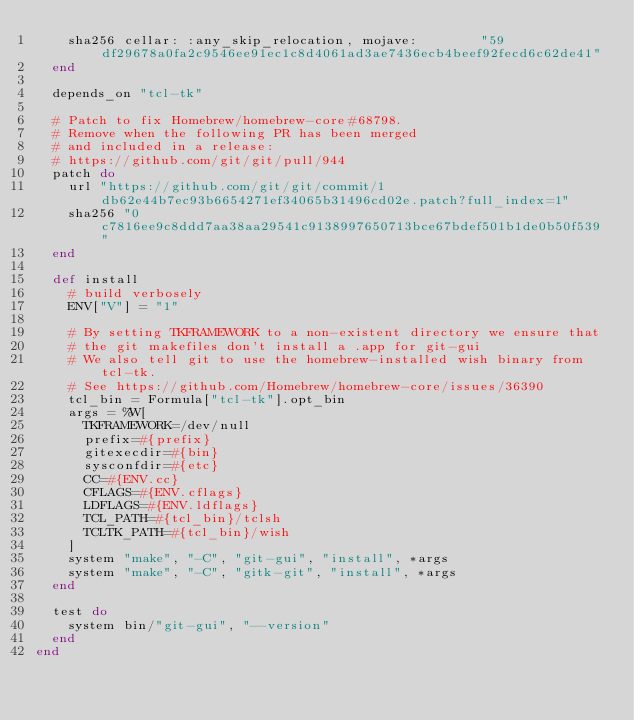<code> <loc_0><loc_0><loc_500><loc_500><_Ruby_>    sha256 cellar: :any_skip_relocation, mojave:        "59df29678a0fa2c9546ee91ec1c8d4061ad3ae7436ecb4beef92fecd6c62de41"
  end

  depends_on "tcl-tk"

  # Patch to fix Homebrew/homebrew-core#68798.
  # Remove when the following PR has been merged
  # and included in a release:
  # https://github.com/git/git/pull/944
  patch do
    url "https://github.com/git/git/commit/1db62e44b7ec93b6654271ef34065b31496cd02e.patch?full_index=1"
    sha256 "0c7816ee9c8ddd7aa38aa29541c9138997650713bce67bdef501b1de0b50f539"
  end

  def install
    # build verbosely
    ENV["V"] = "1"

    # By setting TKFRAMEWORK to a non-existent directory we ensure that
    # the git makefiles don't install a .app for git-gui
    # We also tell git to use the homebrew-installed wish binary from tcl-tk.
    # See https://github.com/Homebrew/homebrew-core/issues/36390
    tcl_bin = Formula["tcl-tk"].opt_bin
    args = %W[
      TKFRAMEWORK=/dev/null
      prefix=#{prefix}
      gitexecdir=#{bin}
      sysconfdir=#{etc}
      CC=#{ENV.cc}
      CFLAGS=#{ENV.cflags}
      LDFLAGS=#{ENV.ldflags}
      TCL_PATH=#{tcl_bin}/tclsh
      TCLTK_PATH=#{tcl_bin}/wish
    ]
    system "make", "-C", "git-gui", "install", *args
    system "make", "-C", "gitk-git", "install", *args
  end

  test do
    system bin/"git-gui", "--version"
  end
end
</code> 